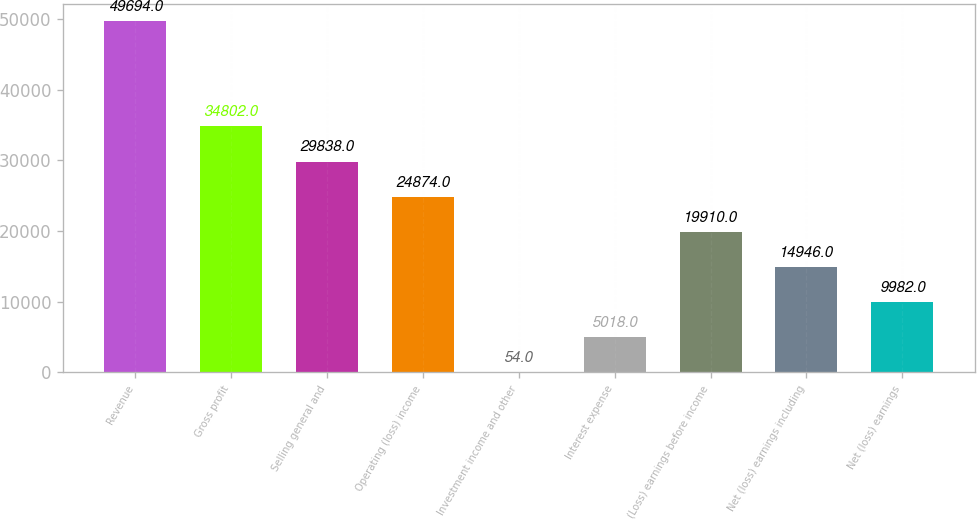Convert chart to OTSL. <chart><loc_0><loc_0><loc_500><loc_500><bar_chart><fcel>Revenue<fcel>Gross profit<fcel>Selling general and<fcel>Operating (loss) income<fcel>Investment income and other<fcel>Interest expense<fcel>(Loss) earnings before income<fcel>Net (loss) earnings including<fcel>Net (loss) earnings<nl><fcel>49694<fcel>34802<fcel>29838<fcel>24874<fcel>54<fcel>5018<fcel>19910<fcel>14946<fcel>9982<nl></chart> 